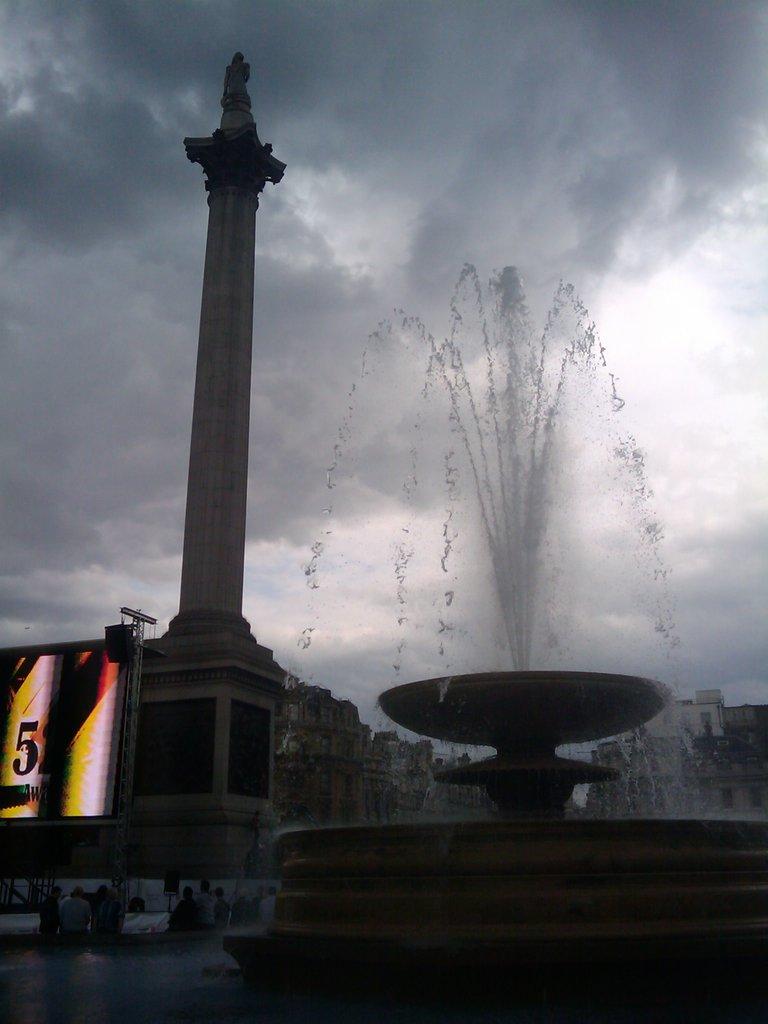What number can be seen?
Make the answer very short. 5. 